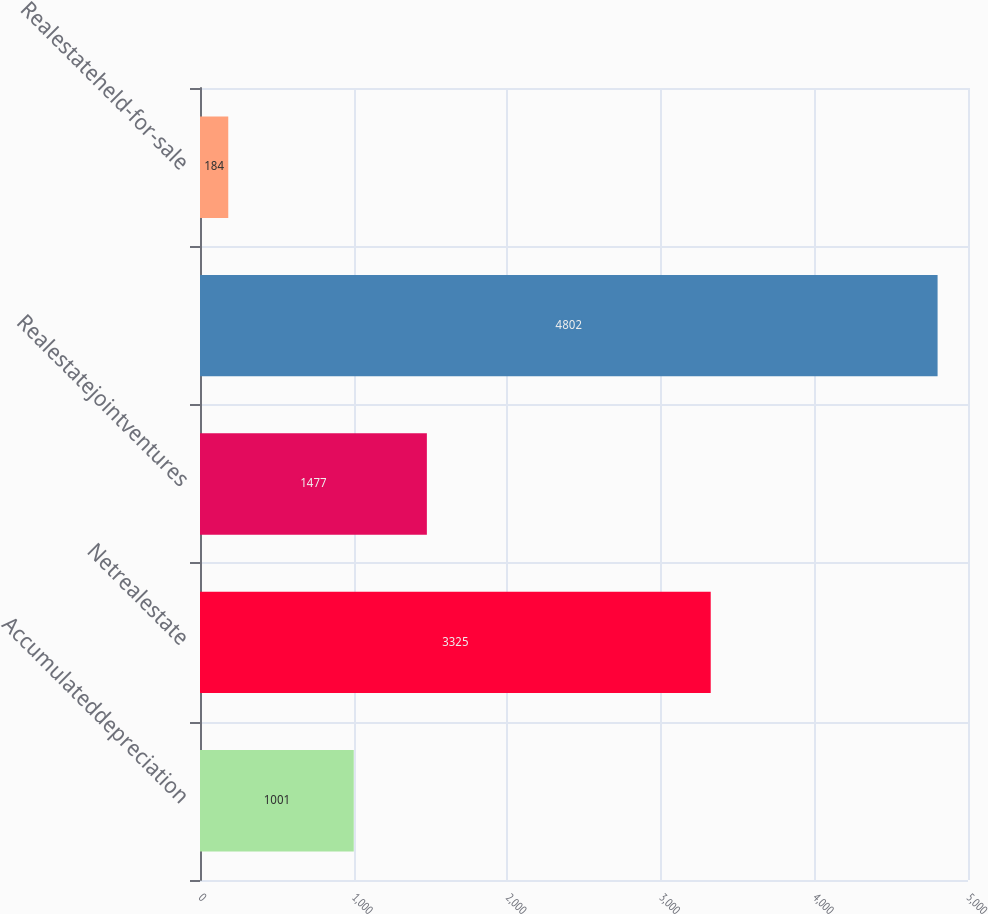<chart> <loc_0><loc_0><loc_500><loc_500><bar_chart><fcel>Accumulateddepreciation<fcel>Netrealestate<fcel>Realestatejointventures<fcel>Unnamed: 3<fcel>Realestateheld-for-sale<nl><fcel>1001<fcel>3325<fcel>1477<fcel>4802<fcel>184<nl></chart> 